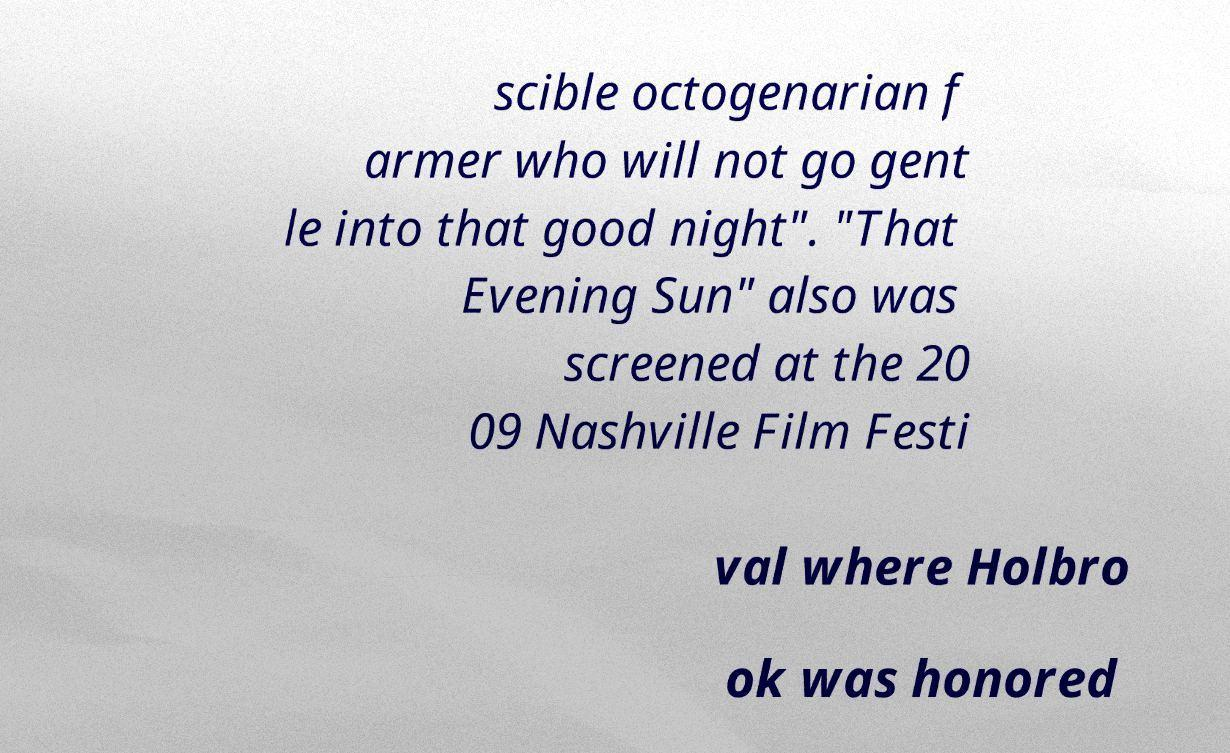What messages or text are displayed in this image? I need them in a readable, typed format. scible octogenarian f armer who will not go gent le into that good night". "That Evening Sun" also was screened at the 20 09 Nashville Film Festi val where Holbro ok was honored 